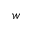<formula> <loc_0><loc_0><loc_500><loc_500>w</formula> 